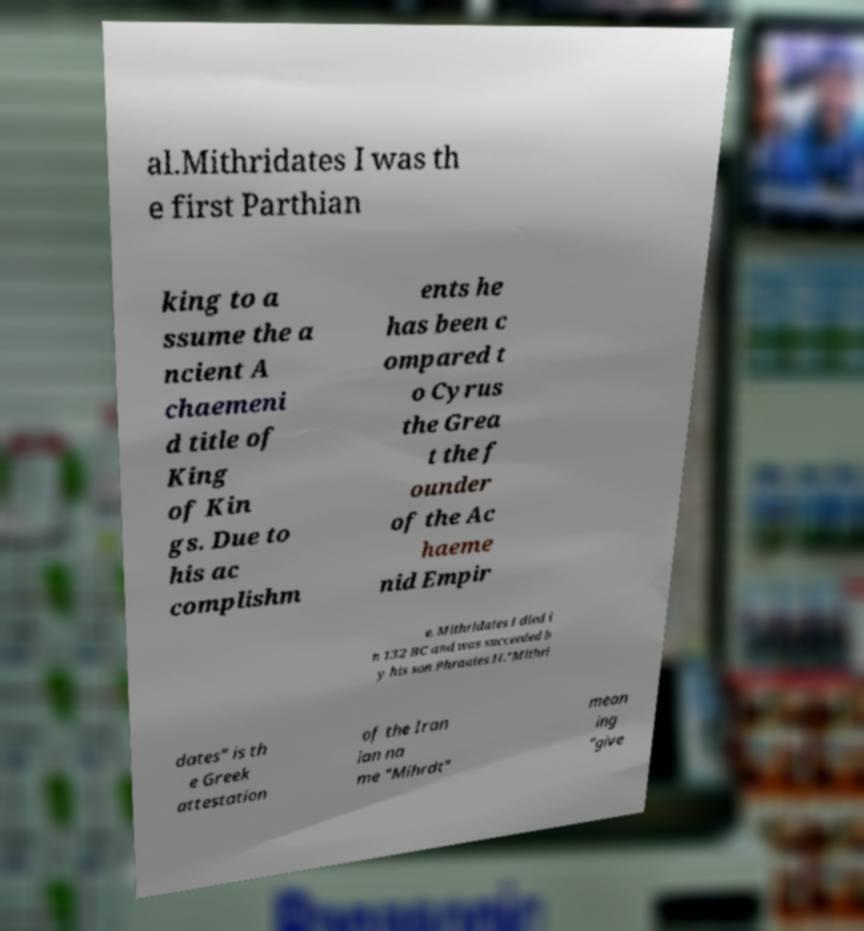What messages or text are displayed in this image? I need them in a readable, typed format. al.Mithridates I was th e first Parthian king to a ssume the a ncient A chaemeni d title of King of Kin gs. Due to his ac complishm ents he has been c ompared t o Cyrus the Grea t the f ounder of the Ac haeme nid Empir e. Mithridates I died i n 132 BC and was succeeded b y his son Phraates II."Mithri dates" is th e Greek attestation of the Iran ian na me "Mihrdt" mean ing "give 